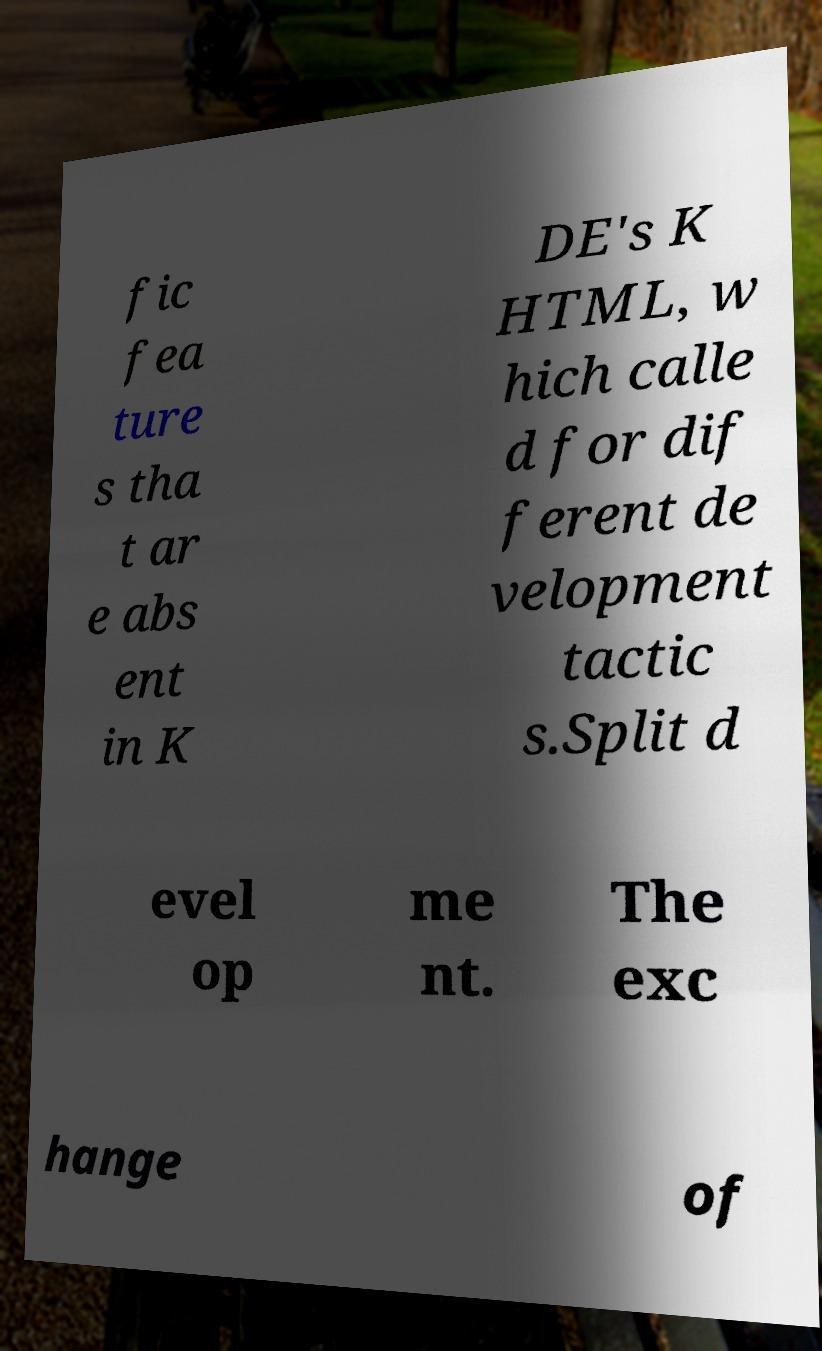I need the written content from this picture converted into text. Can you do that? fic fea ture s tha t ar e abs ent in K DE's K HTML, w hich calle d for dif ferent de velopment tactic s.Split d evel op me nt. The exc hange of 